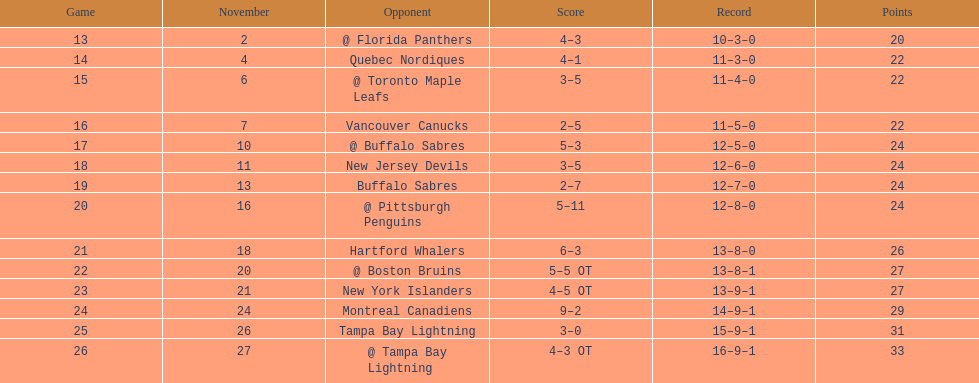Which was the only team in the atlantic division in the 1993-1994 season to acquire less points than the philadelphia flyers? Tampa Bay Lightning. 